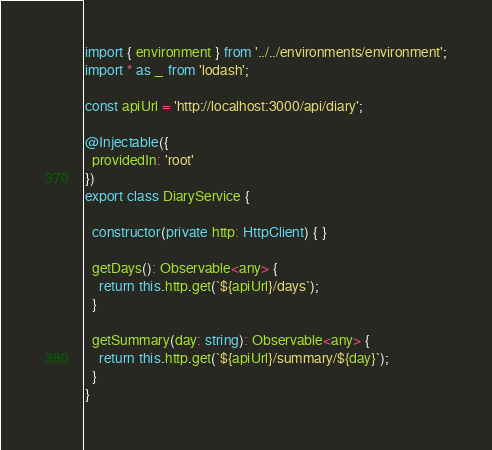<code> <loc_0><loc_0><loc_500><loc_500><_TypeScript_>import { environment } from '../../environments/environment';
import * as _ from 'lodash';

const apiUrl = 'http://localhost:3000/api/diary';

@Injectable({
  providedIn: 'root'
})
export class DiaryService {

  constructor(private http: HttpClient) { }

  getDays(): Observable<any> {
    return this.http.get(`${apiUrl}/days`);
  }

  getSummary(day: string): Observable<any> {
    return this.http.get(`${apiUrl}/summary/${day}`);
  }
}
</code> 